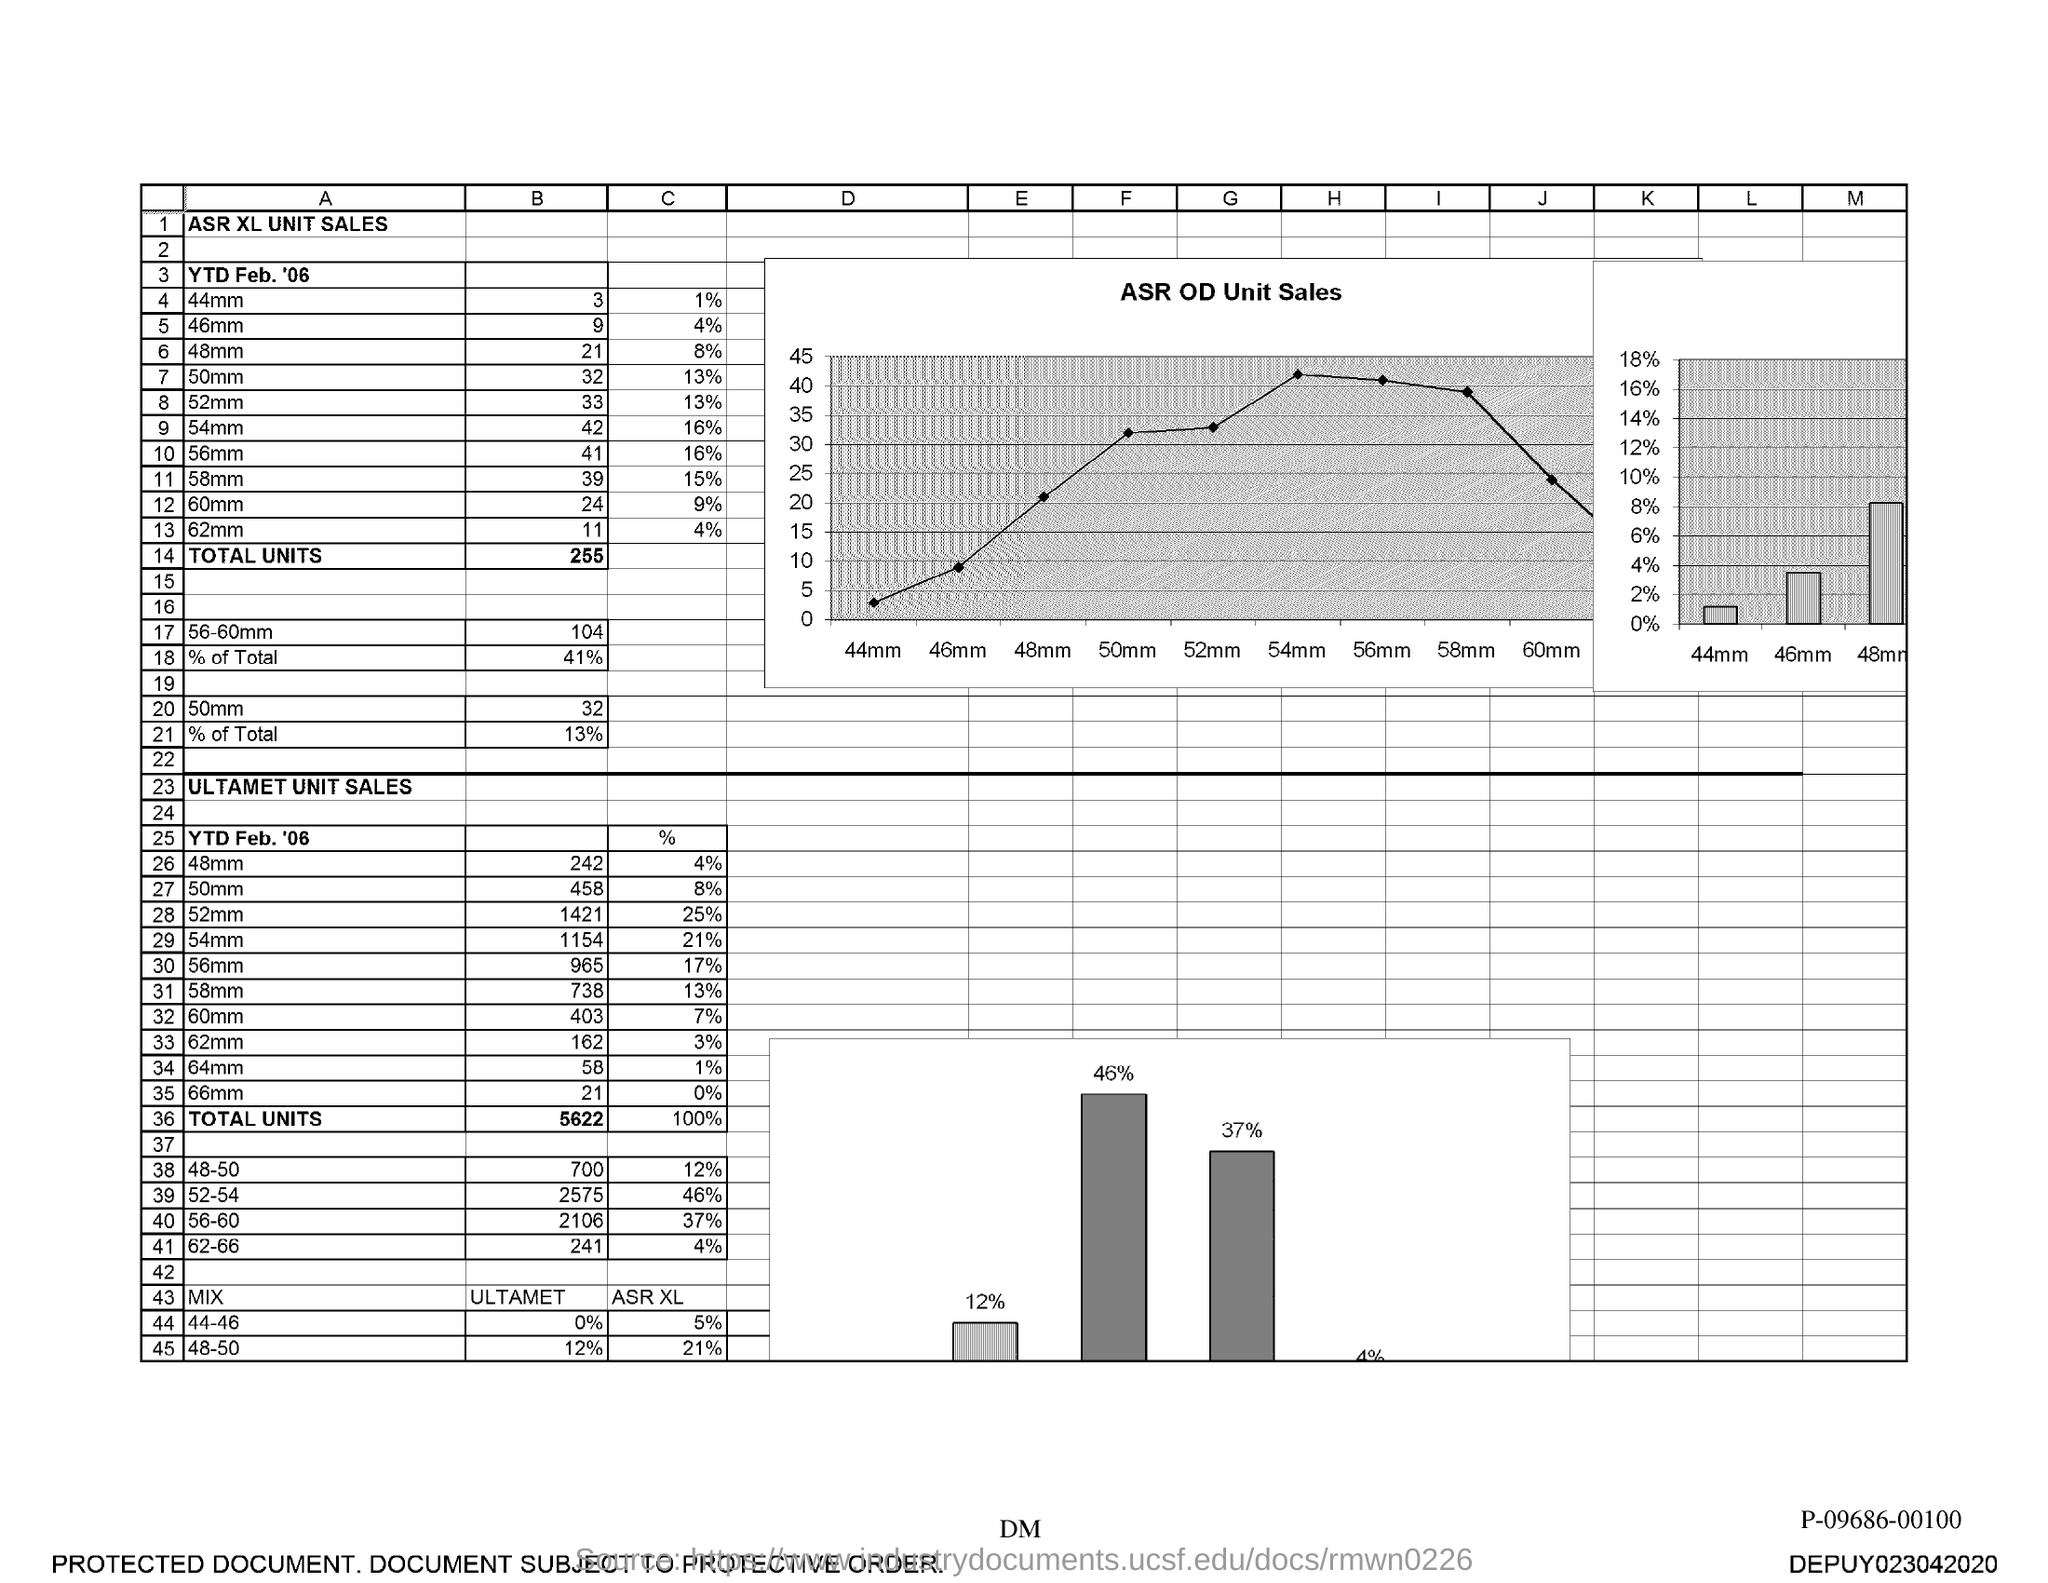What is the ASR XL Unit Sales for YTD Feb '06 for 44mm for "B"?
Your response must be concise. 3. What is the ASR XL Unit Sales for YTD Feb '06 for 46mm for "B"?
Offer a very short reply. 9. What is the ASR XL Unit Sales for YTD Feb '06 for 48mm for "B"?
Offer a terse response. 21. What is the ASR XL Unit Sales for YTD Feb '06 for 50mm for "B"?
Make the answer very short. 32. What is the ASR XL Unit Sales for YTD Feb '06 for 52mm for "B"?
Offer a terse response. 33. What is the ASR XL Unit Sales for YTD Feb '06 for 54mm for "B"?
Offer a terse response. 42. What is the ASR XL Unit Sales for YTD Feb '06 for 56mm for "B"?
Your answer should be compact. 41. What is the ASR XL Unit Sales for YTD Feb '06 for 58mm for "B"?
Your answer should be compact. 39. What is the ASR XL Unit Sales for YTD Feb '06 for 60mm for "B"?
Provide a succinct answer. 24. What is the ASR XL Unit Sales for YTD Feb '06 for 62mm for "B"?
Your answer should be compact. 11. 